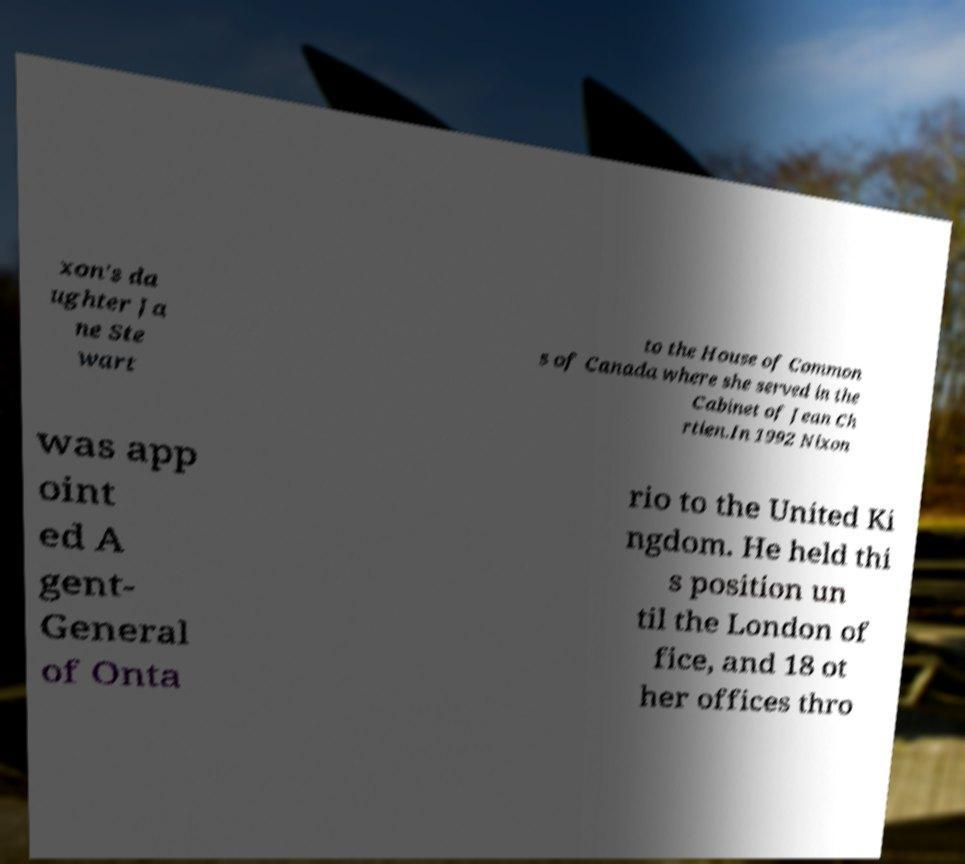For documentation purposes, I need the text within this image transcribed. Could you provide that? xon's da ughter Ja ne Ste wart to the House of Common s of Canada where she served in the Cabinet of Jean Ch rtien.In 1992 Nixon was app oint ed A gent- General of Onta rio to the United Ki ngdom. He held thi s position un til the London of fice, and 18 ot her offices thro 